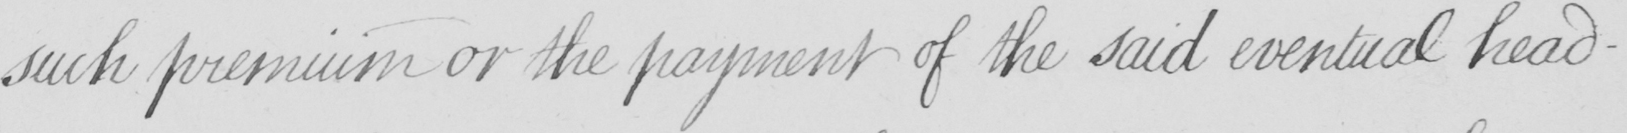What does this handwritten line say? such premium or the payment of the said eventual head- 